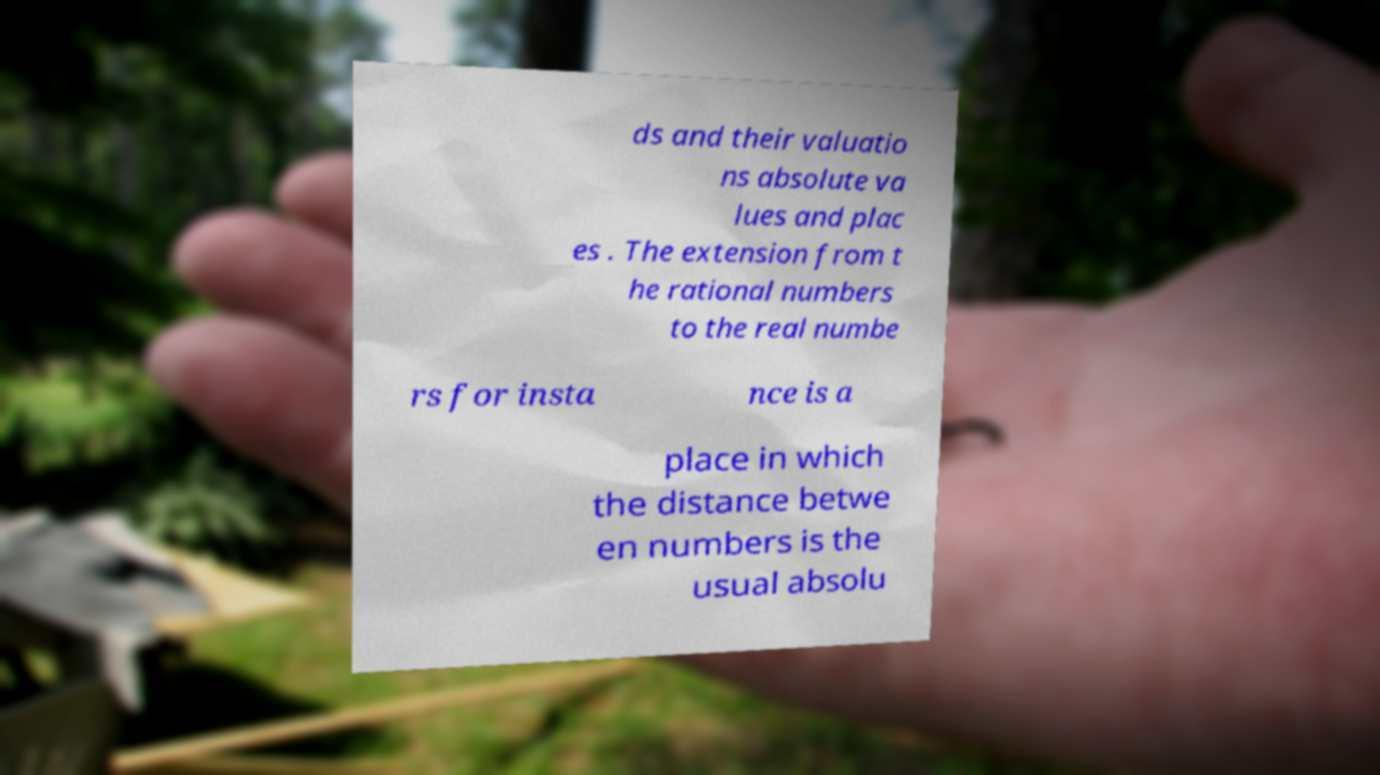Can you read and provide the text displayed in the image?This photo seems to have some interesting text. Can you extract and type it out for me? ds and their valuatio ns absolute va lues and plac es . The extension from t he rational numbers to the real numbe rs for insta nce is a place in which the distance betwe en numbers is the usual absolu 